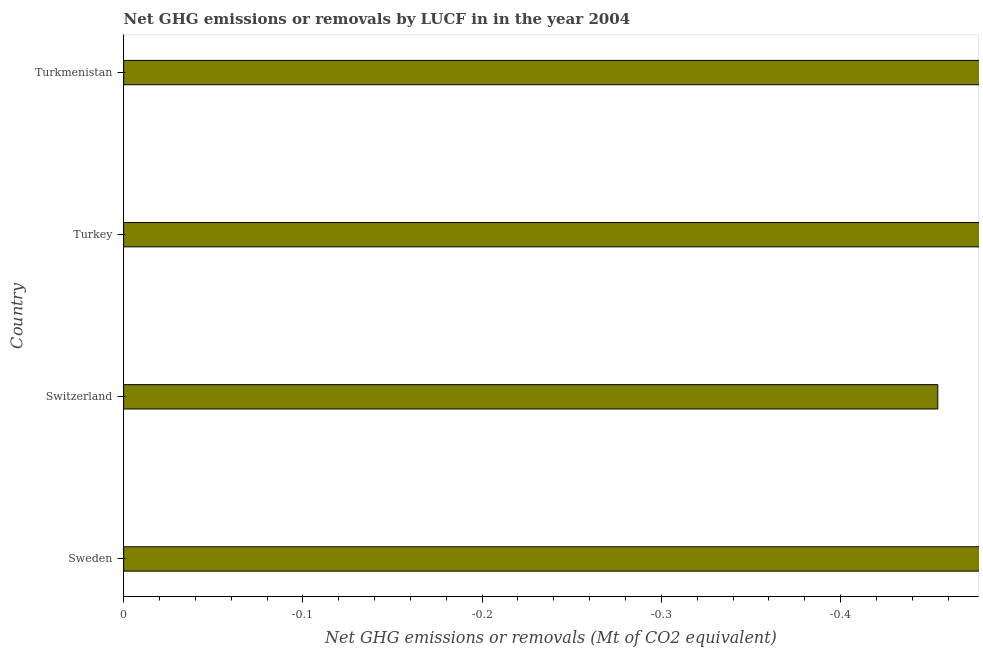Does the graph contain grids?
Offer a very short reply. No. What is the title of the graph?
Your answer should be very brief. Net GHG emissions or removals by LUCF in in the year 2004. What is the label or title of the X-axis?
Ensure brevity in your answer.  Net GHG emissions or removals (Mt of CO2 equivalent). What is the ghg net emissions or removals in Turkmenistan?
Offer a terse response. 0. What is the average ghg net emissions or removals per country?
Provide a succinct answer. 0. What is the median ghg net emissions or removals?
Give a very brief answer. 0. How many bars are there?
Make the answer very short. 0. Are all the bars in the graph horizontal?
Offer a terse response. Yes. What is the difference between two consecutive major ticks on the X-axis?
Your answer should be compact. 0.1. What is the Net GHG emissions or removals (Mt of CO2 equivalent) of Sweden?
Offer a terse response. 0. 